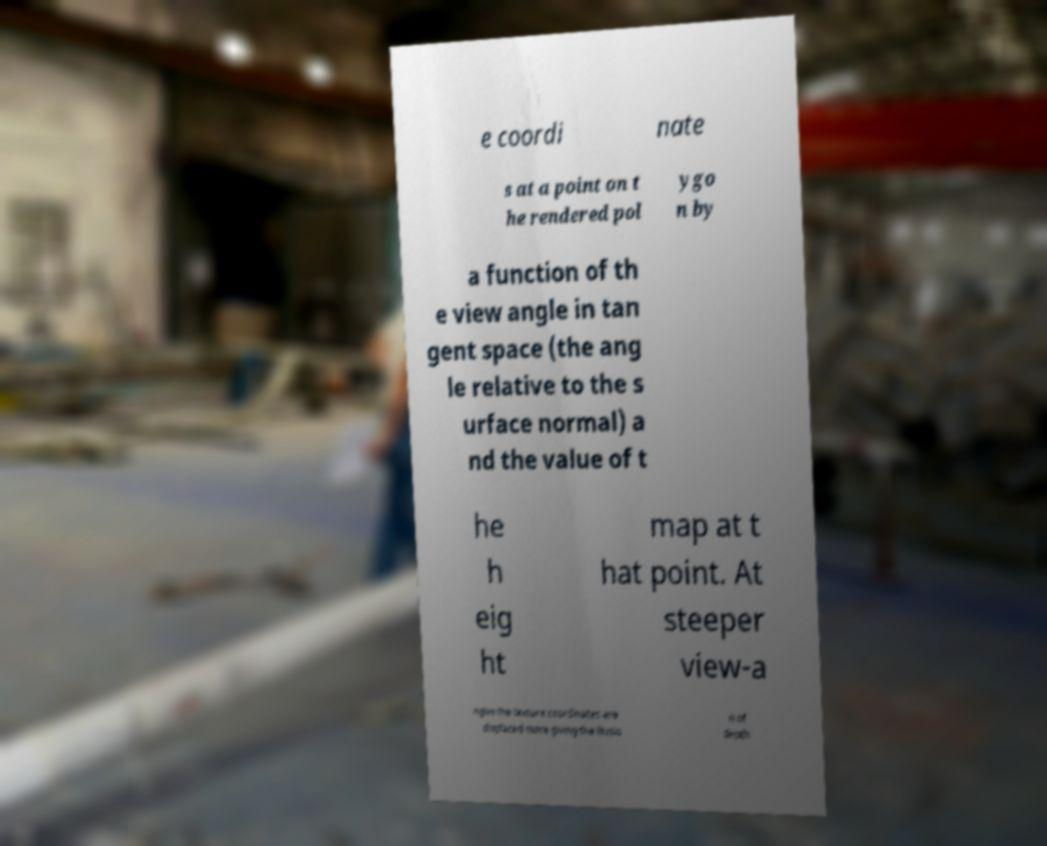Could you assist in decoding the text presented in this image and type it out clearly? e coordi nate s at a point on t he rendered pol ygo n by a function of th e view angle in tan gent space (the ang le relative to the s urface normal) a nd the value of t he h eig ht map at t hat point. At steeper view-a ngles the texture coordinates are displaced more giving the illusio n of depth 